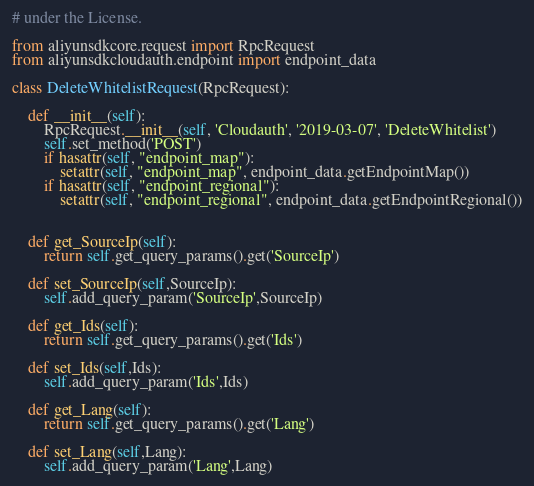Convert code to text. <code><loc_0><loc_0><loc_500><loc_500><_Python_># under the License.

from aliyunsdkcore.request import RpcRequest
from aliyunsdkcloudauth.endpoint import endpoint_data

class DeleteWhitelistRequest(RpcRequest):

	def __init__(self):
		RpcRequest.__init__(self, 'Cloudauth', '2019-03-07', 'DeleteWhitelist')
		self.set_method('POST')
		if hasattr(self, "endpoint_map"):
			setattr(self, "endpoint_map", endpoint_data.getEndpointMap())
		if hasattr(self, "endpoint_regional"):
			setattr(self, "endpoint_regional", endpoint_data.getEndpointRegional())


	def get_SourceIp(self):
		return self.get_query_params().get('SourceIp')

	def set_SourceIp(self,SourceIp):
		self.add_query_param('SourceIp',SourceIp)

	def get_Ids(self):
		return self.get_query_params().get('Ids')

	def set_Ids(self,Ids):
		self.add_query_param('Ids',Ids)

	def get_Lang(self):
		return self.get_query_params().get('Lang')

	def set_Lang(self,Lang):
		self.add_query_param('Lang',Lang)</code> 